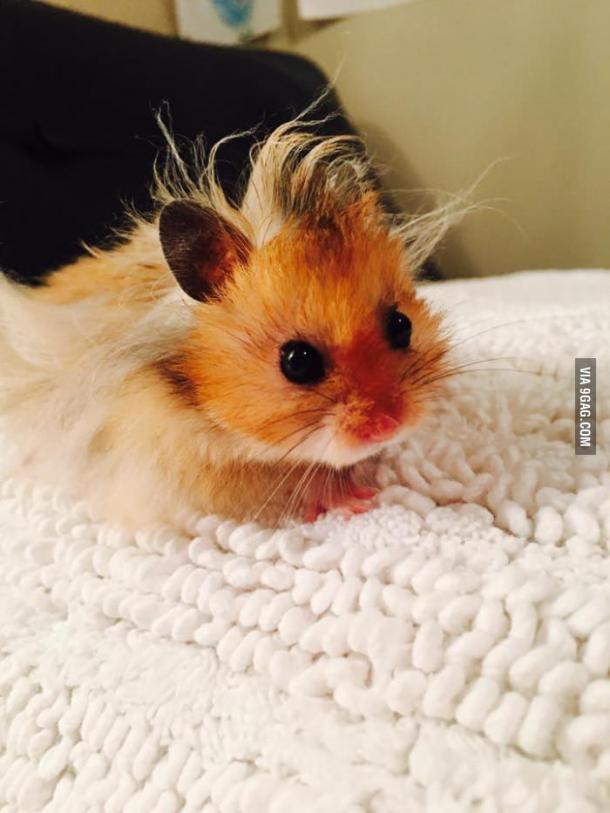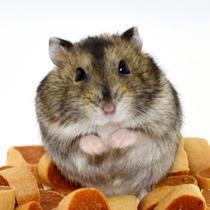The first image is the image on the left, the second image is the image on the right. For the images displayed, is the sentence "Right image shows one pet rodent posed with both front paws off the ground in front of its chest." factually correct? Answer yes or no. Yes. The first image is the image on the left, the second image is the image on the right. Considering the images on both sides, is "One of the images features some of the hamster's food." valid? Answer yes or no. Yes. 